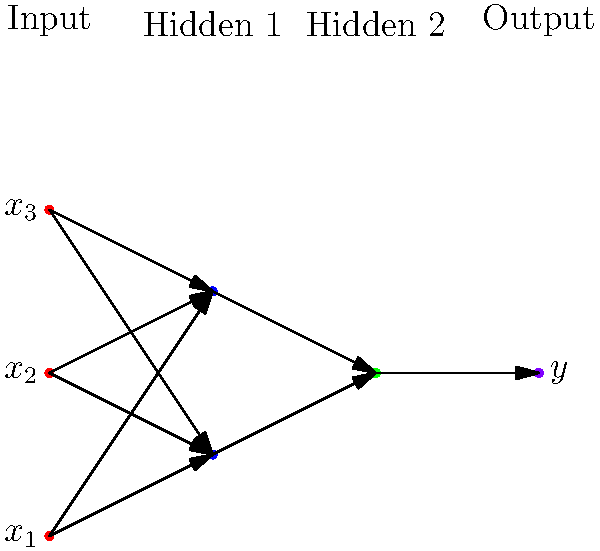Given the neural network architecture diagram for the startup's AI product, what is the maximum number of trainable parameters (weights and biases) in this network, assuming full connectivity between layers? To calculate the maximum number of trainable parameters, we need to count the weights and biases for each layer:

1. Input to Hidden Layer 1:
   - Weights: 3 inputs * 2 neurons = 6
   - Biases: 2 (one for each neuron)

2. Hidden Layer 1 to Hidden Layer 2:
   - Weights: 2 neurons * 1 neuron = 2
   - Biases: 1 (for the single neuron)

3. Hidden Layer 2 to Output:
   - Weights: 1 neuron * 1 output = 1
   - Biases: 1 (for the output neuron)

Total trainable parameters:
$$ 6 + 2 + 2 + 1 + 1 + 1 = 13 $$

This calculation assumes full connectivity between layers and includes a bias term for each neuron, which is the standard approach in most neural network architectures.
Answer: 13 parameters 